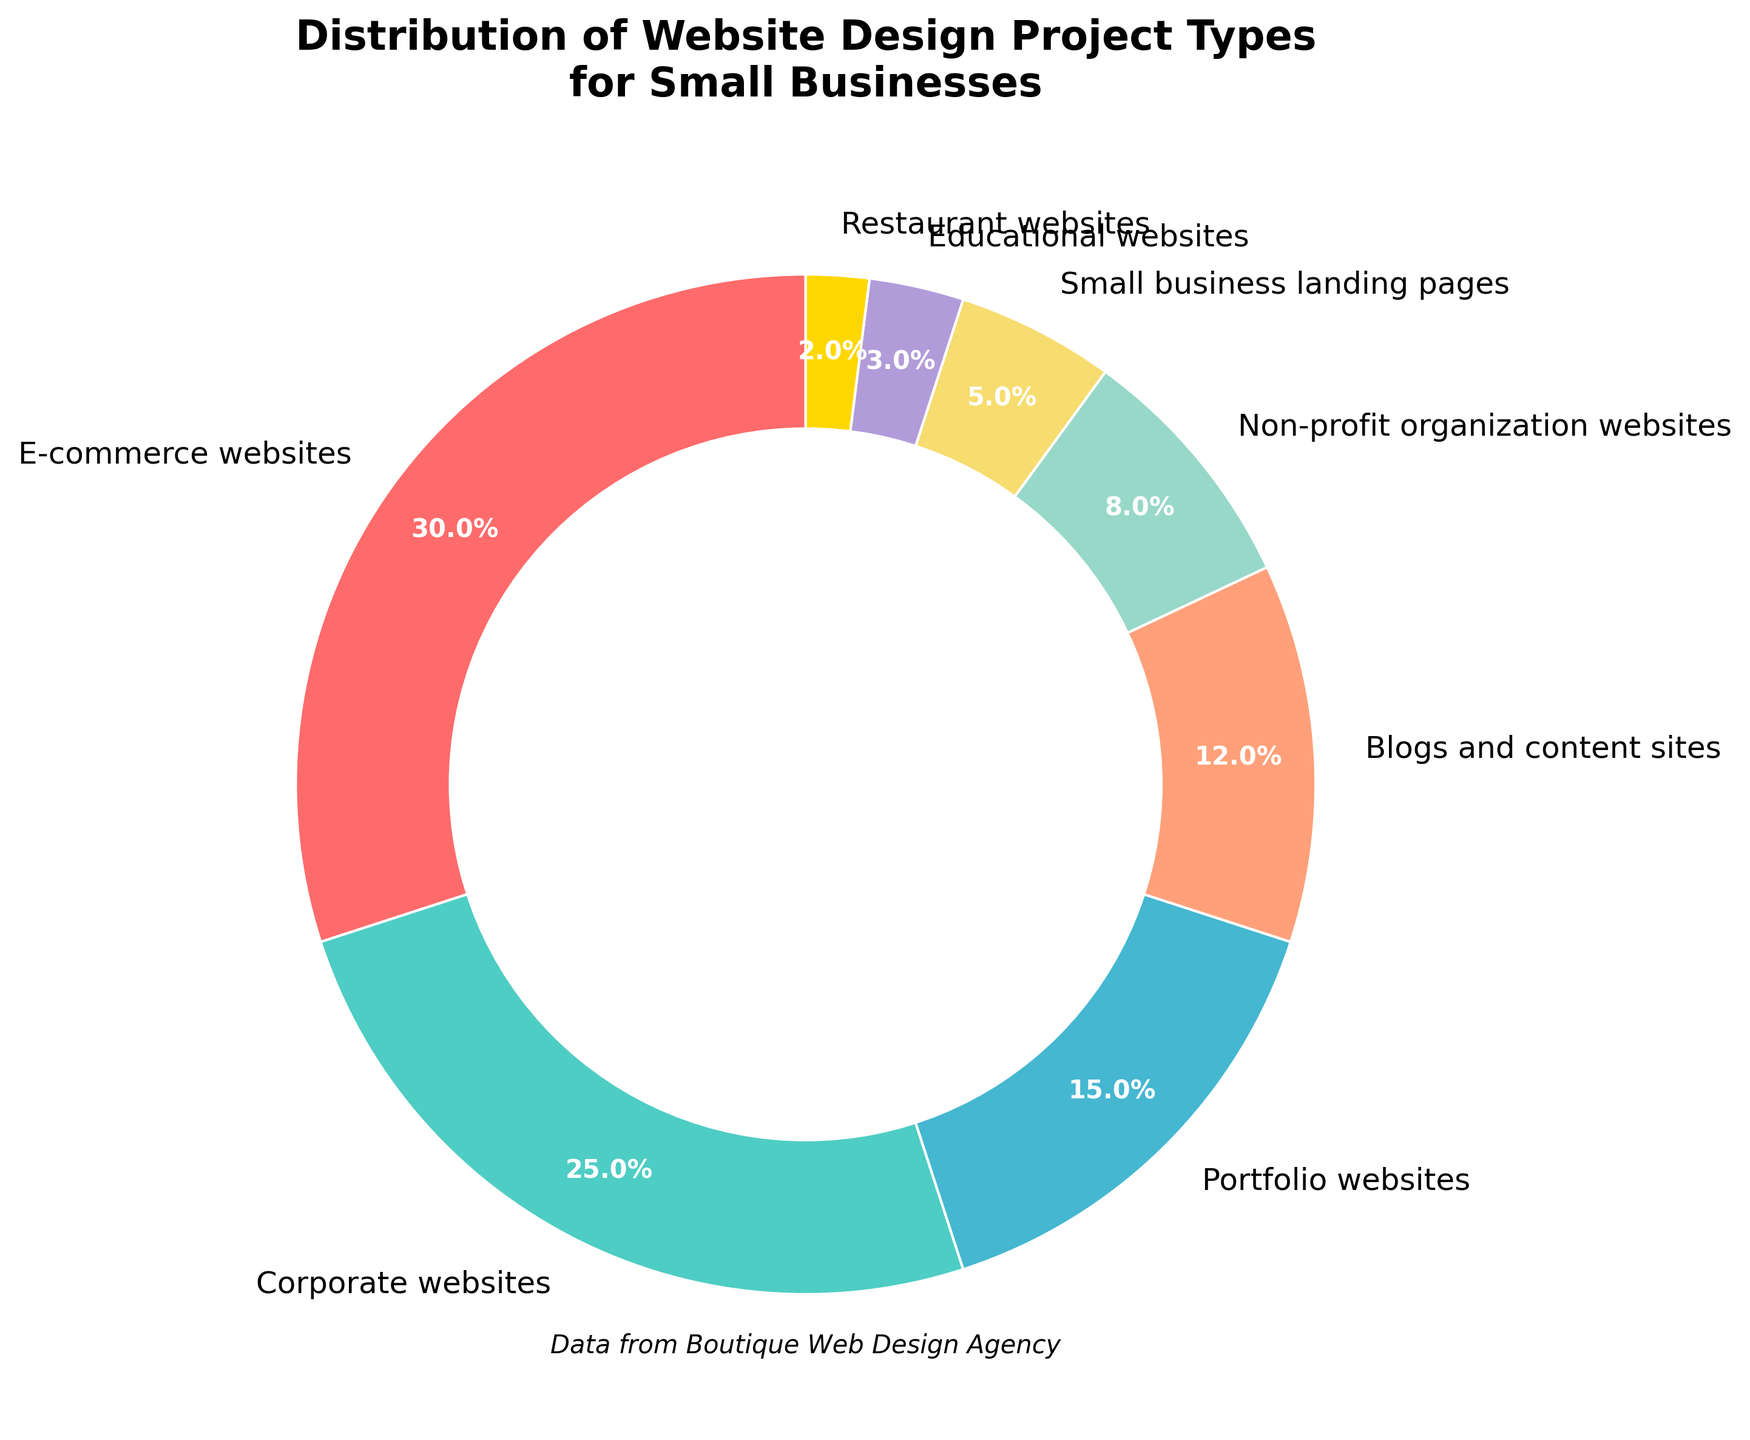Which project type has the highest percentage? The largest wedge in the pie chart, representing 30%, corresponds to E-commerce websites.
Answer: E-commerce websites Which project type has the smallest representation? The smallest wedge in the pie chart, representing 2%, corresponds to Restaurant websites.
Answer: Restaurant websites What is the combined percentage of E-commerce websites and Corporate websites? Add the percentages of E-commerce websites (30%) and Corporate websites (25%). 30% + 25% = 55%.
Answer: 55% Compare the percentage of Non-profit organization websites to Educational websites. Which is greater and by how much? Non-profit organization websites have 8% while Educational websites have 3%. 8% - 3% = 5%. Non-profit organization websites exceed Educational websites by 5%.
Answer: Non-profit organizations by 5% Which sections are shown in shades of blue and green? The Blog and content sites (12%) and Non-profit organization websites (8%) are respectively colored in shades of blue and green based on the visual cues in the pie chart.
Answer: Blog and content sites, Non-profit organization websites Is the percentage of Portfolio websites more or less than half of E-commerce websites? Half of E-commerce websites' percentage is 30% / 2 = 15%. Portfolio websites are also 15%, so the percentage is equal to half of E-commerce websites.
Answer: Equal What percentage of projects goes to Portfolio websites and Blogs and content sites combined? Add the percentages of Portfolio websites (15%) and Blogs and content sites (12%). 15% + 12% = 27%.
Answer: 27% What is the difference in percentage points between the top three project types and the rest combined? Add the percentages of the top three types: E-commerce websites (30%), Corporate websites (25%), and Portfolio websites (15%) which equals 70%. Total percentage is 100%, so the rest combined is 100% - 70% = 30%. Difference is 70% - 30% = 40%.
Answer: 40% Which two project types combined make up the smallest percentage, and what is their total? Restaurant websites (2%) and Educational websites (3%) combined make the smallest percentage, totaling 2% + 3% = 5%.
Answer: Restaurant and Educational, 5% How much larger is the percentage of Blogs and content sites compared to Small business landing pages? Blogs and content sites have 12% and Small business landing pages have 5%. The difference is 12% - 5% = 7%.
Answer: 7% 